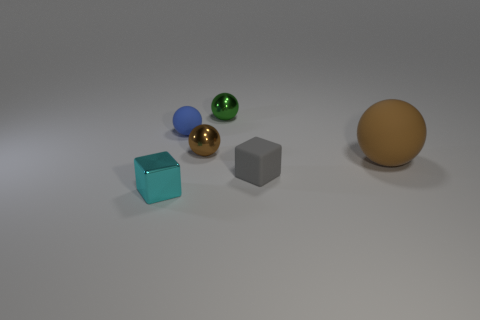There is a matte thing behind the brown rubber ball; what size is it?
Ensure brevity in your answer.  Small. What shape is the other object that is the same color as the big object?
Give a very brief answer. Sphere. Does the tiny cyan object have the same material as the small ball right of the tiny brown ball?
Keep it short and to the point. Yes. There is a small block left of the thing that is behind the tiny blue rubber thing; how many tiny things are behind it?
Provide a short and direct response. 4. How many green objects are either metal blocks or tiny metallic spheres?
Your response must be concise. 1. What shape is the rubber object that is behind the big matte ball?
Your response must be concise. Sphere. The rubber cube that is the same size as the brown metallic thing is what color?
Offer a very short reply. Gray. There is a brown metal object; does it have the same shape as the thing in front of the gray rubber cube?
Offer a terse response. No. What material is the tiny cyan cube that is in front of the sphere that is on the right side of the tiny cube that is on the right side of the cyan object?
Make the answer very short. Metal. How many small things are either red metal objects or brown matte things?
Offer a very short reply. 0. 